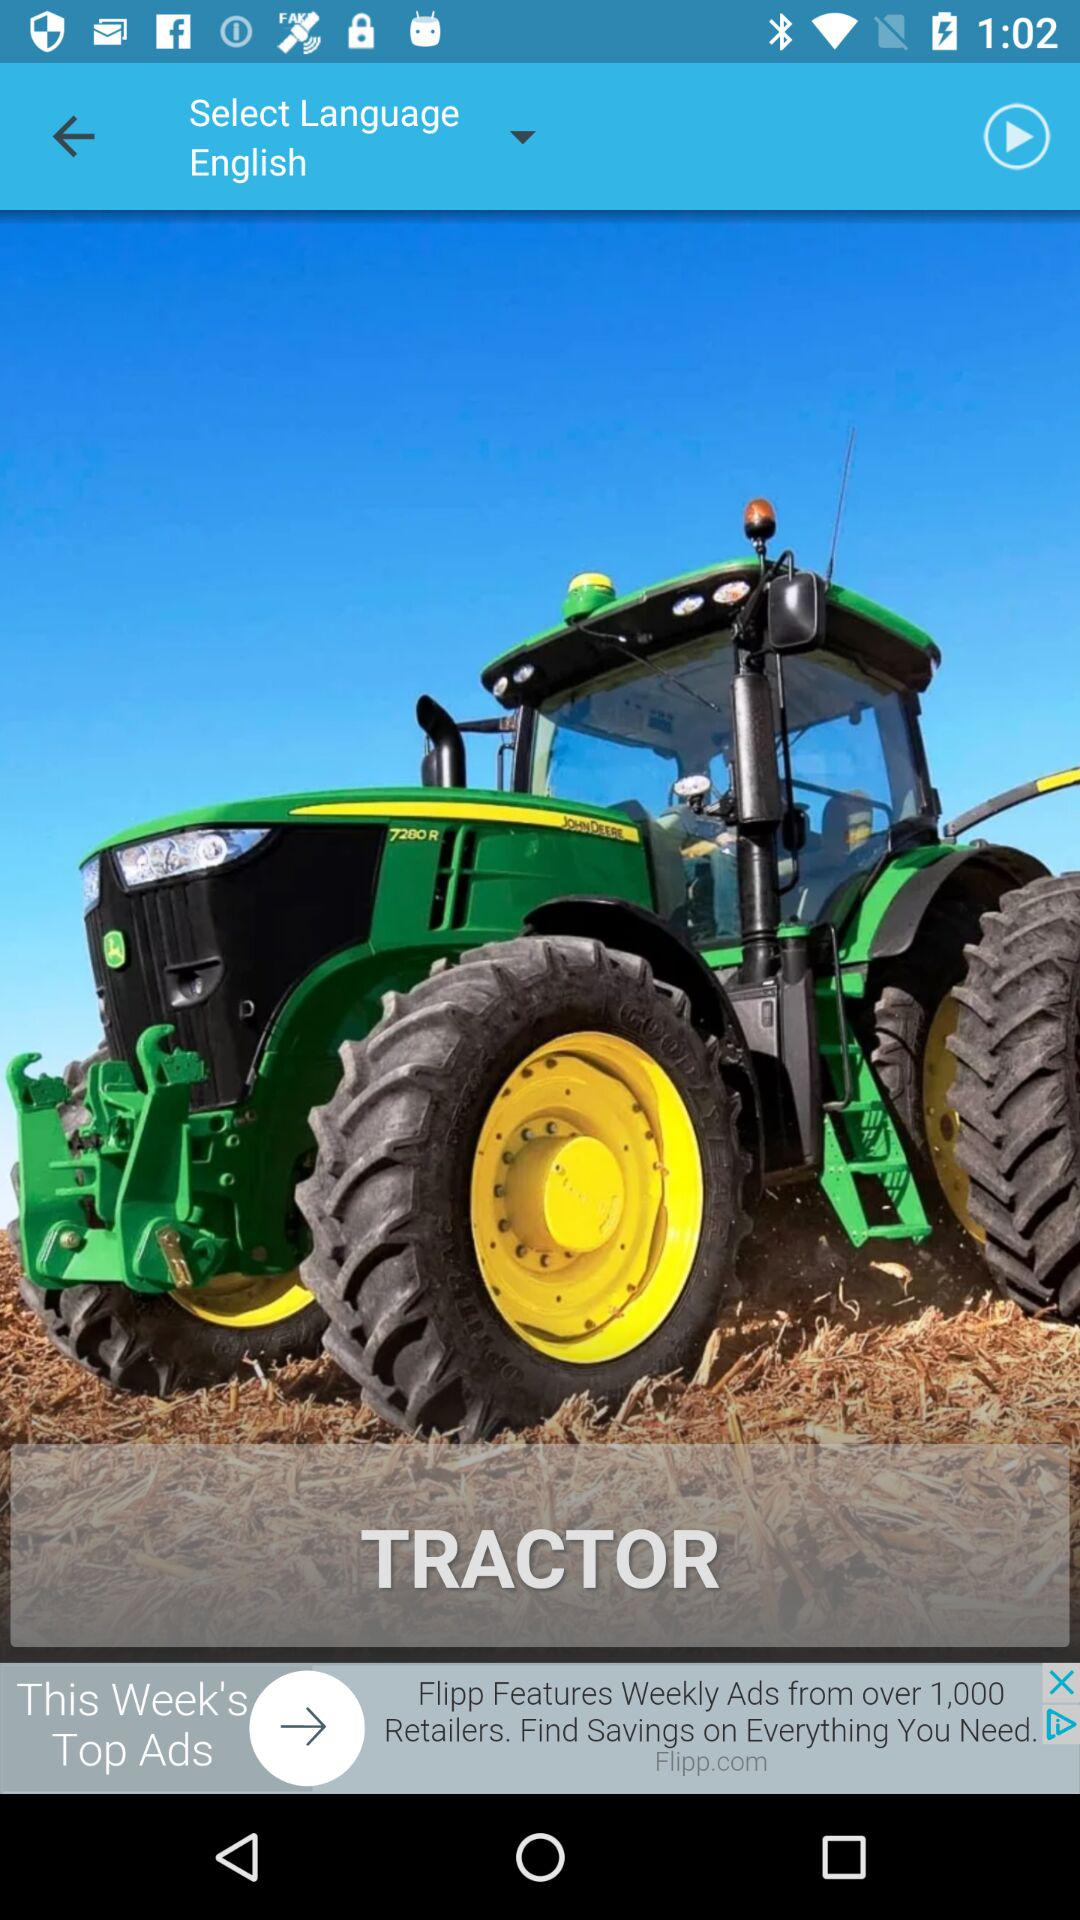Which language is selected? The selected language is English. 